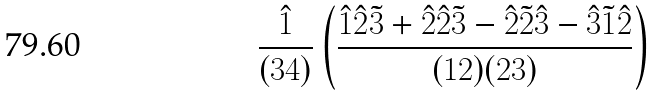Convert formula to latex. <formula><loc_0><loc_0><loc_500><loc_500>\frac { \hat { 1 } } { ( 3 4 ) } \left ( \frac { \hat { 1 } \hat { 2 } \tilde { 3 } + \hat { 2 } \hat { 2 } \tilde { 3 } - \hat { 2 } \tilde { 2 } \hat { 3 } - \hat { 3 } \tilde { 1 } \hat { 2 } } { ( 1 2 ) ( 2 3 ) } \right )</formula> 